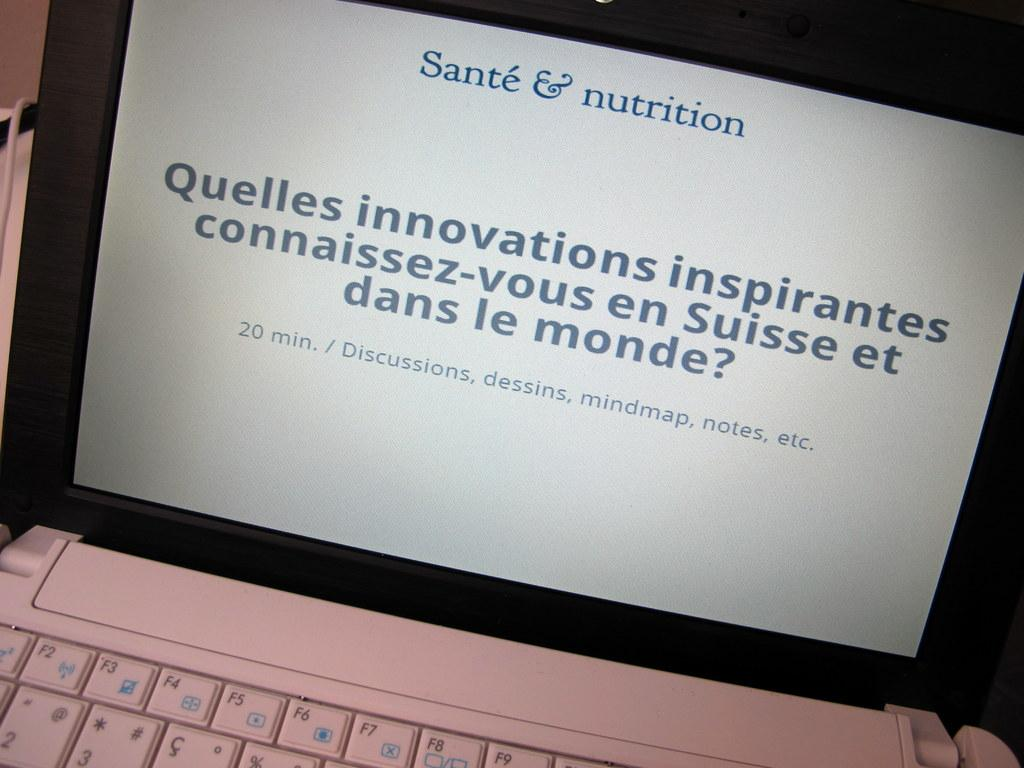<image>
Share a concise interpretation of the image provided. Sante & Nutrition is the header of the site shown on this laptop. 